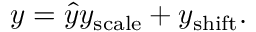<formula> <loc_0><loc_0><loc_500><loc_500>y = { \hat { y } } y _ { s c a l e } + y _ { s h i f t } .</formula> 